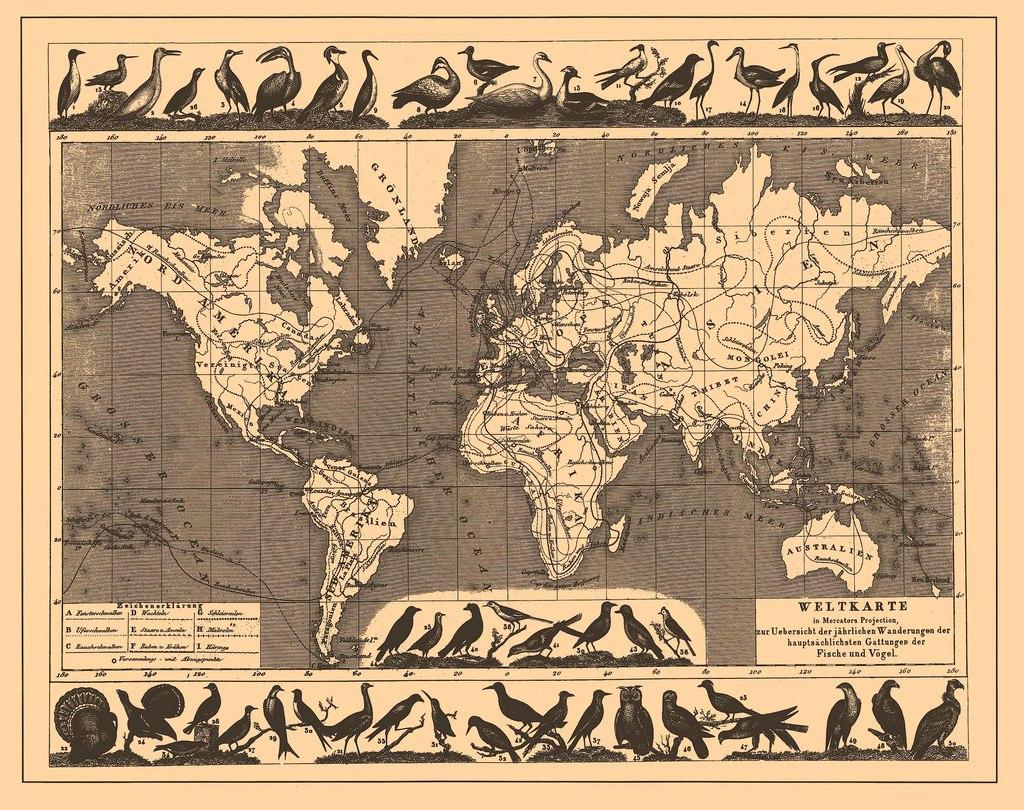What is written at the top of the box in the bottom right?
Provide a short and direct response. Weltkarte. What is the word printed across the island in the bottom right?
Provide a succinct answer. Australien. 